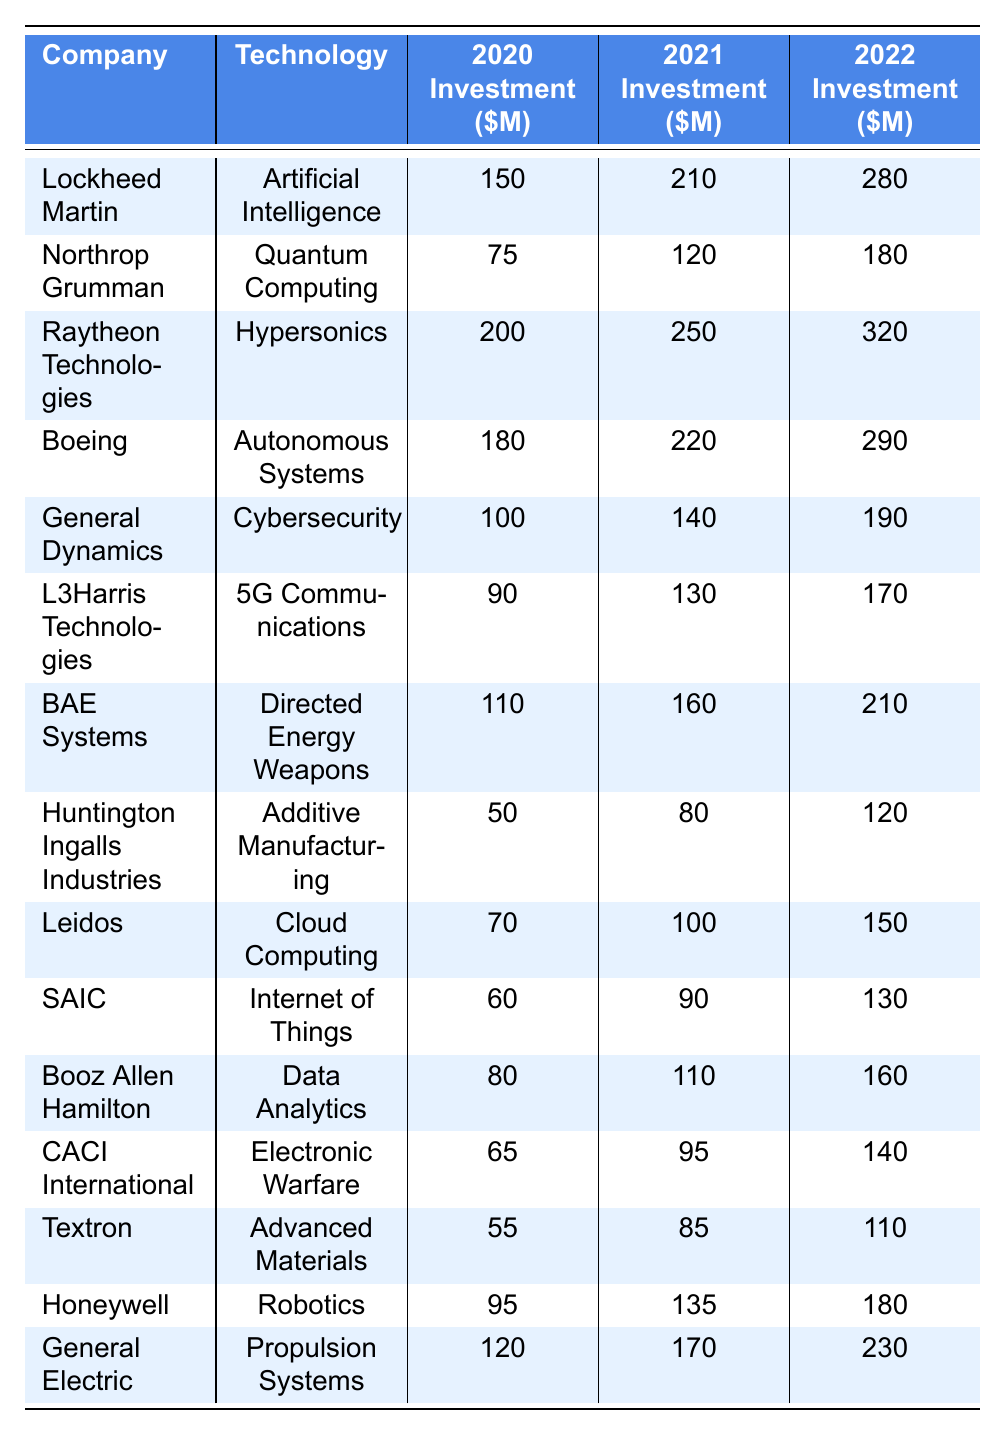What was Lockheed Martin's investment in Artificial Intelligence for 2021? The table shows that Lockheed Martin invested 210 million dollars in Artificial Intelligence in 2021.
Answer: 210 million dollars Which company invested the most in Hypersonics in 2022? According to the table, Raytheon Technologies invested 320 million dollars in Hypersonics in 2022, which is higher than the other companies listed.
Answer: Raytheon Technologies What was the total investment of Boeing in Autonomous Systems from 2020 to 2022? Adding Boeing's investments from 2020 (180 million), 2021 (220 million), and 2022 (290 million) gives us a total of 690 million dollars (180 + 220 + 290 = 690).
Answer: 690 million dollars Which technology saw the highest investment growth from 2020 to 2022? The investment in Hypersonics by Raytheon Technologies grew from 200 million in 2020 to 320 million in 2022, showing a growth of 120 million dollars (320 - 200 = 120). This is the highest growth compared to other technologies.
Answer: Hypersonics Did L3Harris Technologies increase their investment in 5G Communications every year? By examining the table, L3Harris Technologies invested 90 million in 2020, 130 million in 2021, and 170 million in 2022, indicating annual increases. Therefore, the answer is yes.
Answer: Yes What was the average investment across all technologies in 2021? Summing the investments for all companies in 2021 gives 2,295 million dollars (210 + 120 + 250 + 220 + 140 + 130 + 160 + 80 + 100 + 90 + 110 + 95 + 85 + 135 + 170 = 2,295). There are 15 companies, so the average is 2,295/15 = 153 million dollars.
Answer: 153 million dollars Which company had the lowest total investment across all years and what was that total? By summing the investments for Huntington Ingalls Industries (50 + 80 + 120 = 250 million dollars), we see that this is the lowest total among the companies listed.
Answer: 250 million dollars Is there a company that invested equally in two consecutive years? Examining the investments shows that there is no company with the same investment amount for two consecutive years in the table. Therefore, the answer is no.
Answer: No What was the percentage increase in investment for General Electric from 2020 to 2022? General Electric's investment rose from 120 million in 2020 to 230 million in 2022. The increase is 110 million dollars (230 - 120 = 110). The percentage increase is (110/120) * 100 = 91.67%.
Answer: 91.67% Which technology received the largest total investment across all three years? Summing the investments for Hypersonics yields a total of 770 million dollars (200 + 250 + 320 = 770 million dollars), which is the highest among all technologies.
Answer: Hypersonics How many companies invested more than 150 million dollars in 2022? The table shows Lockheed Martin (280), Raytheon Technologies (320), Boeing (290), and General Electric (230) invested more than 150 million dollars in 2022. This gives us a total of 4 companies.
Answer: 4 